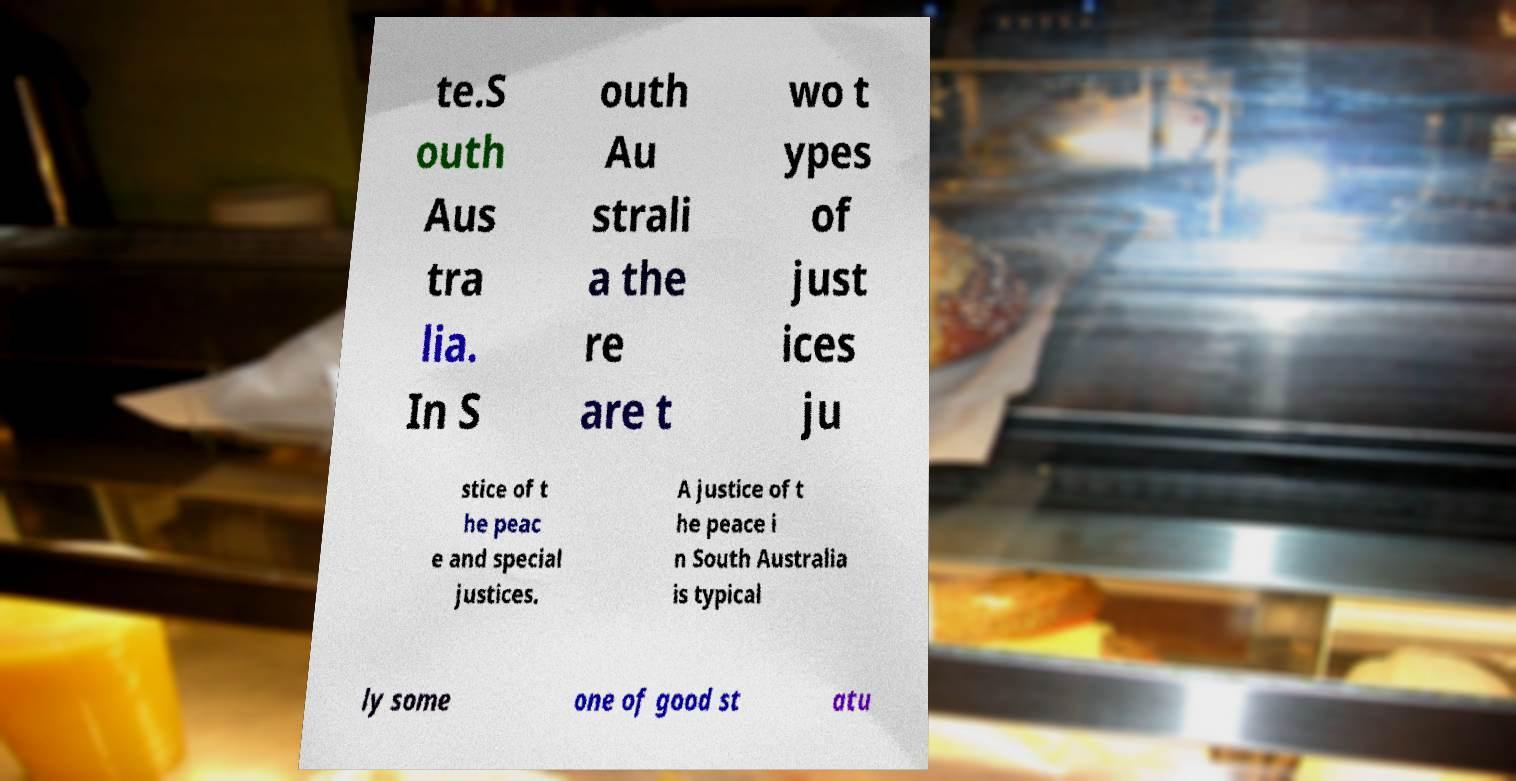Please identify and transcribe the text found in this image. te.S outh Aus tra lia. In S outh Au strali a the re are t wo t ypes of just ices ju stice of t he peac e and special justices. A justice of t he peace i n South Australia is typical ly some one of good st atu 